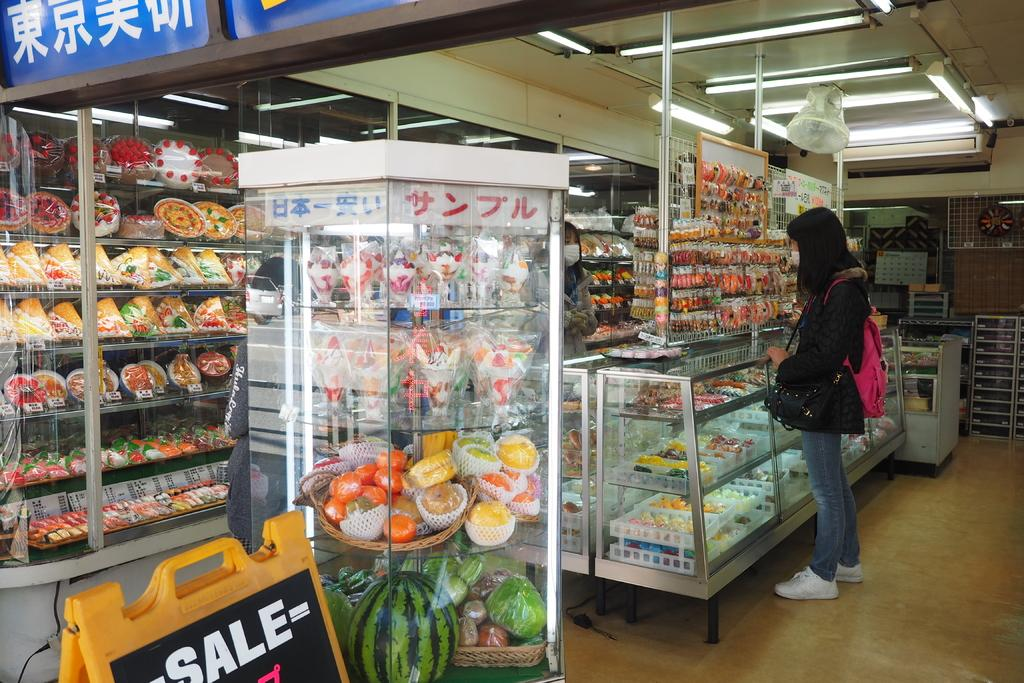Provide a one-sentence caption for the provided image. A woman standing next to a food display with a "SALE" sign nearby. 